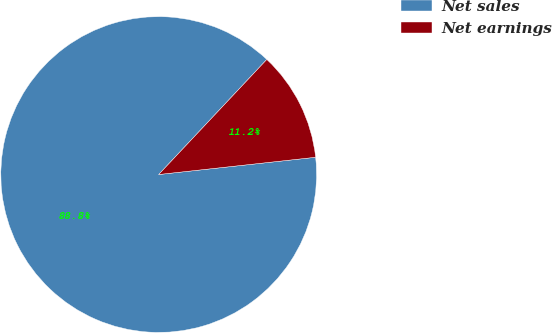<chart> <loc_0><loc_0><loc_500><loc_500><pie_chart><fcel>Net sales<fcel>Net earnings<nl><fcel>88.75%<fcel>11.25%<nl></chart> 